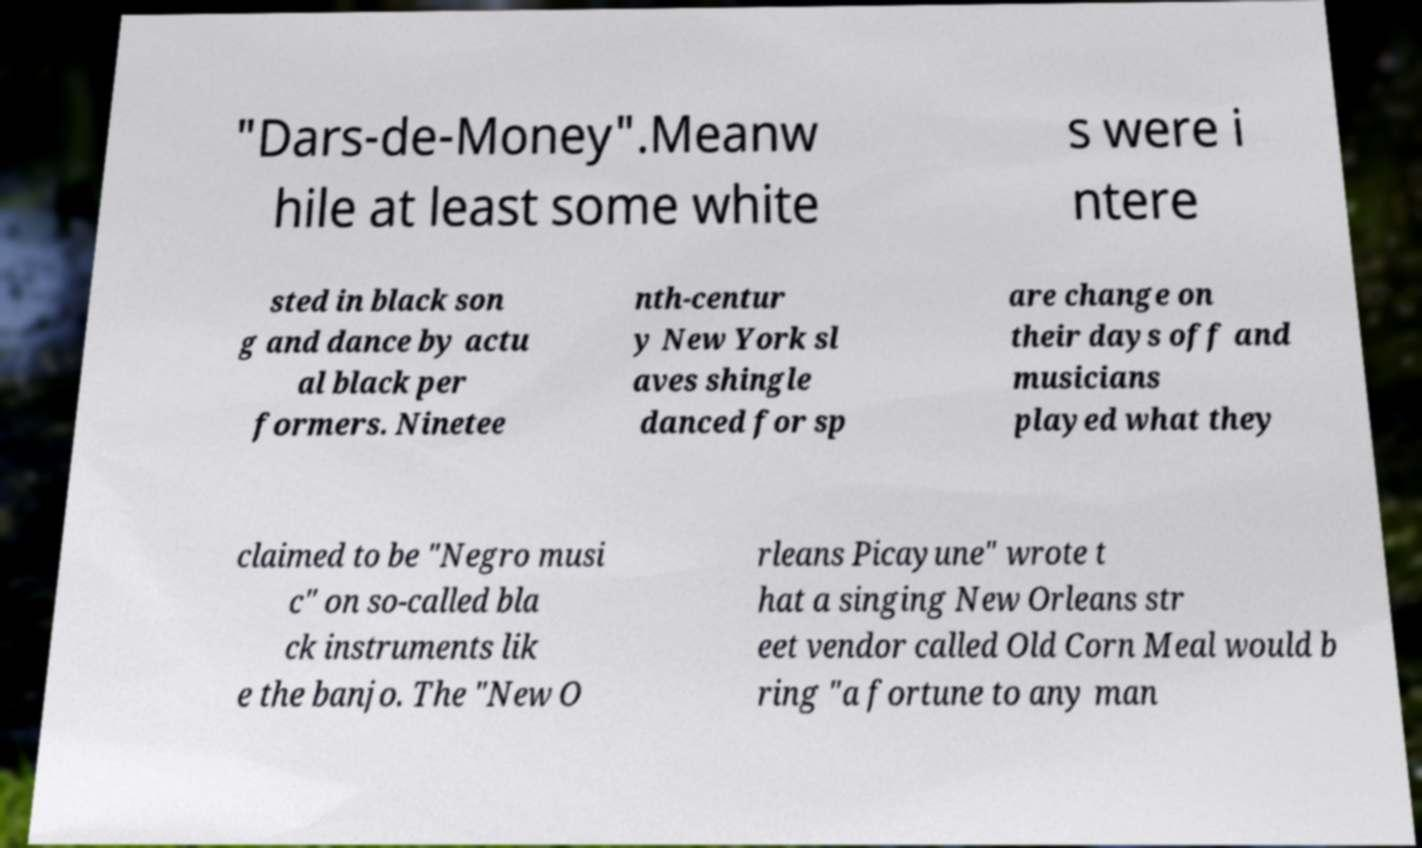Please identify and transcribe the text found in this image. "Dars-de-Money".Meanw hile at least some white s were i ntere sted in black son g and dance by actu al black per formers. Ninetee nth-centur y New York sl aves shingle danced for sp are change on their days off and musicians played what they claimed to be "Negro musi c" on so-called bla ck instruments lik e the banjo. The "New O rleans Picayune" wrote t hat a singing New Orleans str eet vendor called Old Corn Meal would b ring "a fortune to any man 